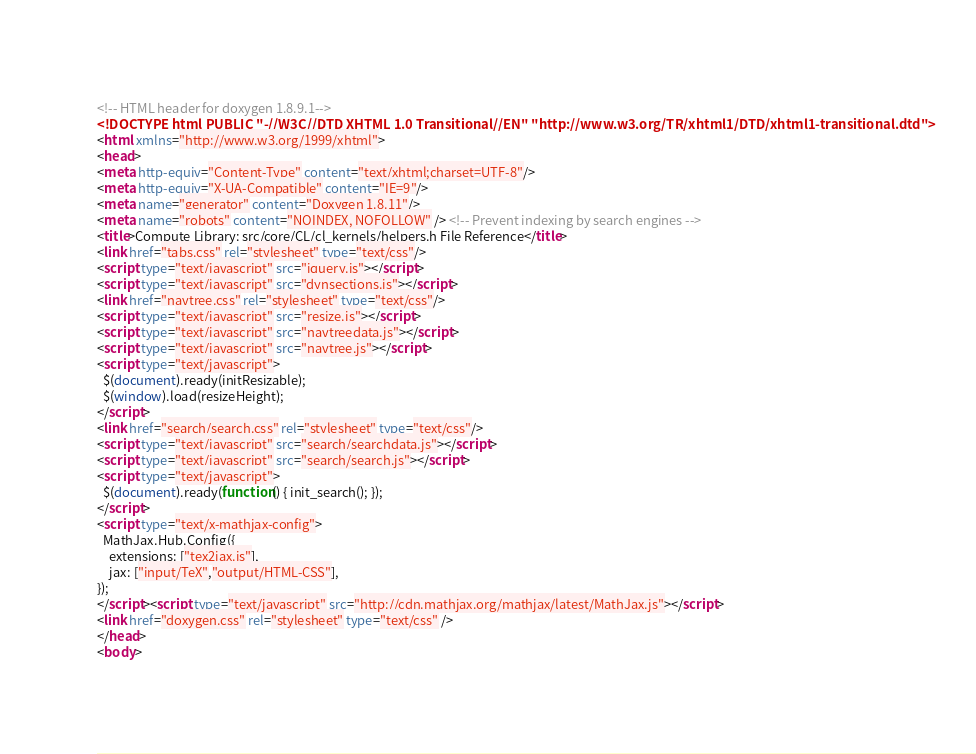<code> <loc_0><loc_0><loc_500><loc_500><_HTML_><!-- HTML header for doxygen 1.8.9.1-->
<!DOCTYPE html PUBLIC "-//W3C//DTD XHTML 1.0 Transitional//EN" "http://www.w3.org/TR/xhtml1/DTD/xhtml1-transitional.dtd">
<html xmlns="http://www.w3.org/1999/xhtml">
<head>
<meta http-equiv="Content-Type" content="text/xhtml;charset=UTF-8"/>
<meta http-equiv="X-UA-Compatible" content="IE=9"/>
<meta name="generator" content="Doxygen 1.8.11"/>
<meta name="robots" content="NOINDEX, NOFOLLOW" /> <!-- Prevent indexing by search engines -->
<title>Compute Library: src/core/CL/cl_kernels/helpers.h File Reference</title>
<link href="tabs.css" rel="stylesheet" type="text/css"/>
<script type="text/javascript" src="jquery.js"></script>
<script type="text/javascript" src="dynsections.js"></script>
<link href="navtree.css" rel="stylesheet" type="text/css"/>
<script type="text/javascript" src="resize.js"></script>
<script type="text/javascript" src="navtreedata.js"></script>
<script type="text/javascript" src="navtree.js"></script>
<script type="text/javascript">
  $(document).ready(initResizable);
  $(window).load(resizeHeight);
</script>
<link href="search/search.css" rel="stylesheet" type="text/css"/>
<script type="text/javascript" src="search/searchdata.js"></script>
<script type="text/javascript" src="search/search.js"></script>
<script type="text/javascript">
  $(document).ready(function() { init_search(); });
</script>
<script type="text/x-mathjax-config">
  MathJax.Hub.Config({
    extensions: ["tex2jax.js"],
    jax: ["input/TeX","output/HTML-CSS"],
});
</script><script type="text/javascript" src="http://cdn.mathjax.org/mathjax/latest/MathJax.js"></script>
<link href="doxygen.css" rel="stylesheet" type="text/css" />
</head>
<body></code> 